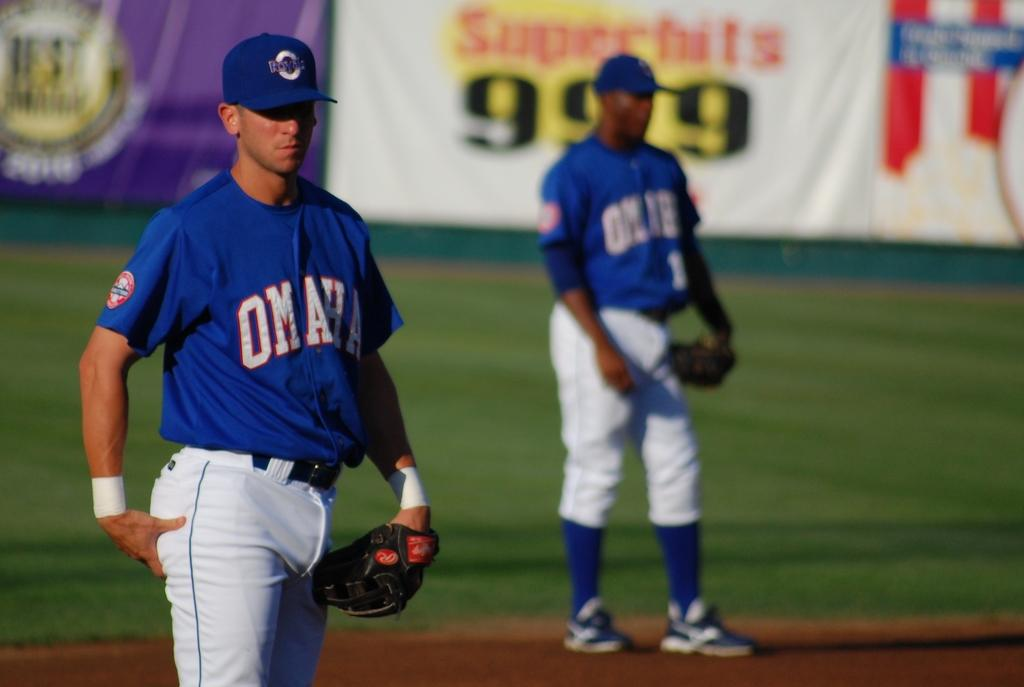<image>
Relay a brief, clear account of the picture shown. Baseball players for Omaha are in the outfield. 